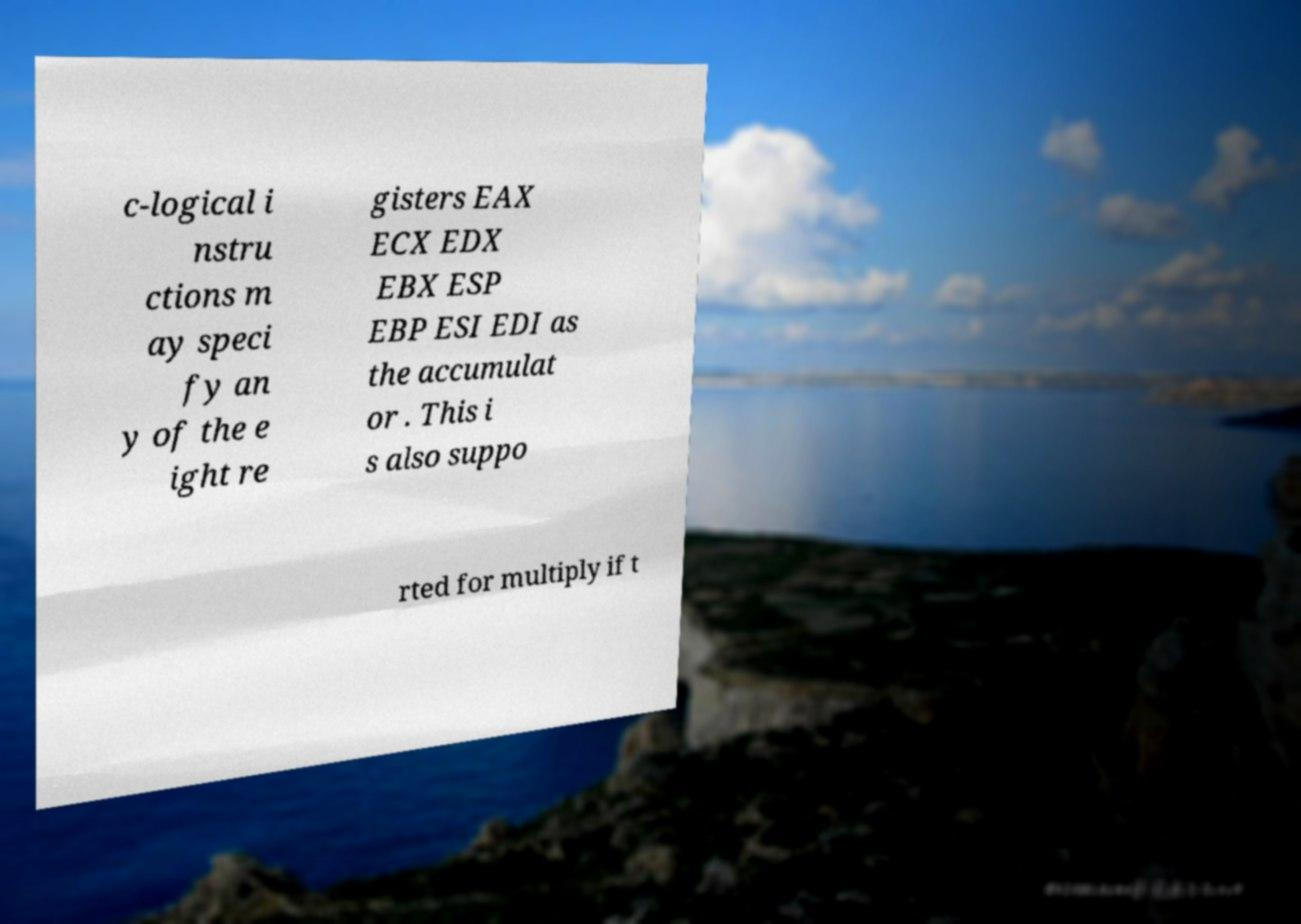Can you accurately transcribe the text from the provided image for me? c-logical i nstru ctions m ay speci fy an y of the e ight re gisters EAX ECX EDX EBX ESP EBP ESI EDI as the accumulat or . This i s also suppo rted for multiply if t 